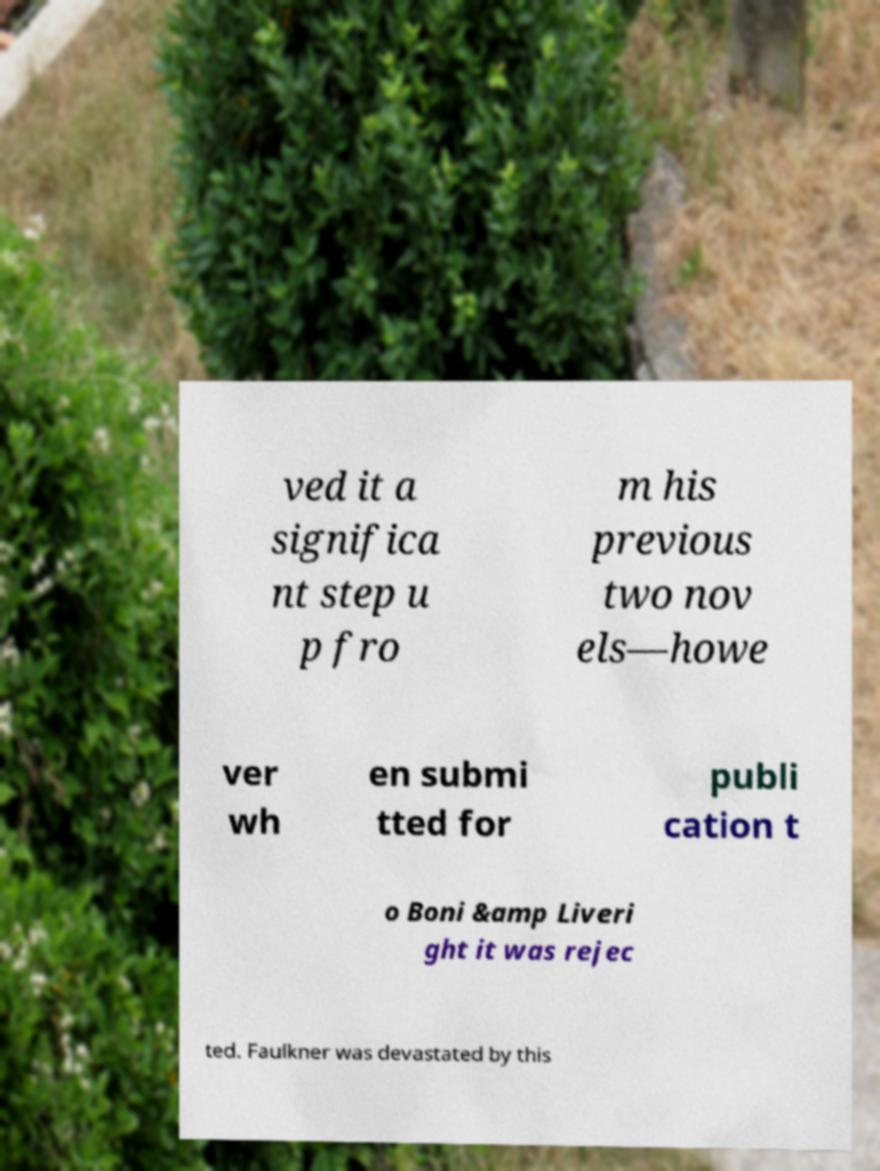I need the written content from this picture converted into text. Can you do that? ved it a significa nt step u p fro m his previous two nov els—howe ver wh en submi tted for publi cation t o Boni &amp Liveri ght it was rejec ted. Faulkner was devastated by this 